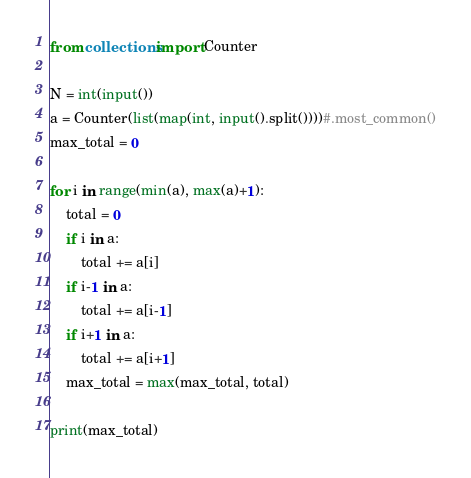<code> <loc_0><loc_0><loc_500><loc_500><_Python_>from collections import Counter

N = int(input())
a = Counter(list(map(int, input().split())))#.most_common()
max_total = 0

for i in range(min(a), max(a)+1):
    total = 0
    if i in a:
        total += a[i]
    if i-1 in a:
        total += a[i-1]
    if i+1 in a:
        total += a[i+1]
    max_total = max(max_total, total)
    
print(max_total)</code> 